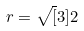Convert formula to latex. <formula><loc_0><loc_0><loc_500><loc_500>r = \sqrt { [ } 3 ] { 2 }</formula> 